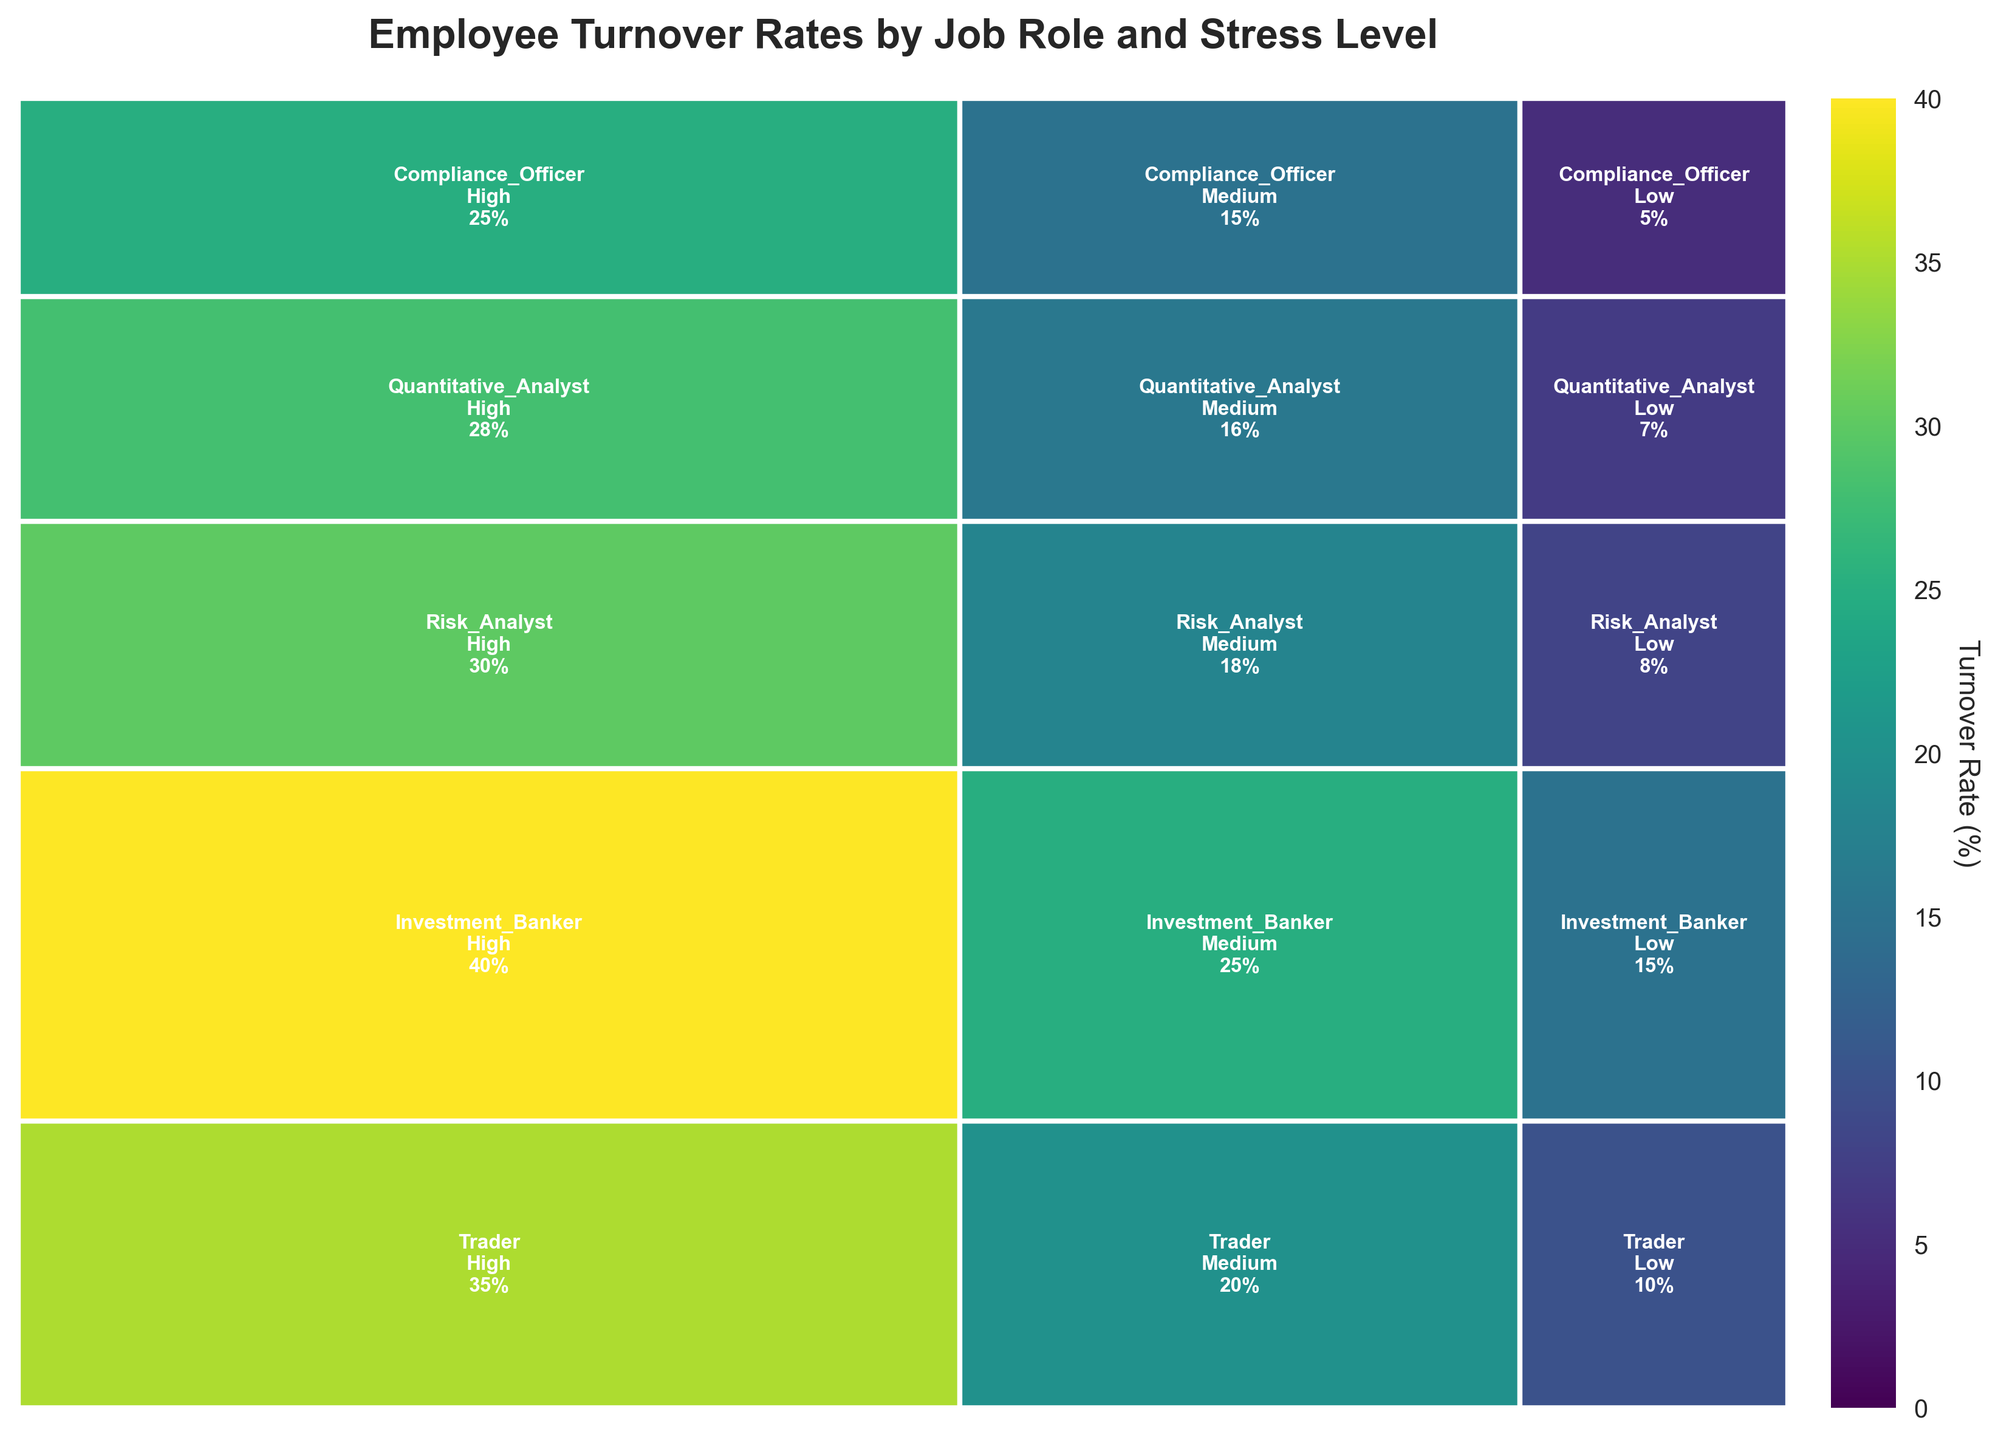How many job roles are displayed in the plot? The plot shows one tile for each job role, with multiple subdivisions per stress level. Counting the distinct job roles, we have Trader, Investment Banker, Risk Analyst, Quantitative Analyst, and Compliance Officer.
Answer: 5 Which stress level leads to the highest turnover rate for Investment Bankers? Each stress level (High, Medium, Low) is indicated within the Investment Banker tile. By analyzing the values within this tile, the highest turnover rate is observed under the High stress level which is 40%.
Answer: High Which job role has the lowest turnover rate under high stress? Each job role within the high stress level (the leftmost side of the plot) has its corresponding turnover rate. Comparing these, Compliance Officer has the lowest turnover rate at 25%.
Answer: Compliance Officer What is the total turnover rate for Risk Analysts across all stress levels? Sum up the turnover rates for Risk Analysts: 30% (High) + 18% (Medium) + 8% (Low) = 56%.
Answer: 56% Compare the turnover rates of Traders and Compliance Officers under medium stress. By looking at the values within the medium stress level subdivisions for each job role, Traders have a turnover rate of 20%, while Compliance Officers have a turnover rate of 15%. Traders have a higher turnover rate.
Answer: Traders Which stress level shows the lowest turnover rate overall? Summing the turnovers by each stress level across all job roles: High = 35%+40%+30%+28%+25% = 158%, Medium = 20%+25%+18%+16%+15% = 94%, Low = 10%+15%+8%+7%+5% = 45%. The Low stress level has the lowest total turnover rate.
Answer: Low What portion of the total turnover rate does the Quantitative Analyst's turnover under high stress constitute? First, compute the total turnover rate for all roles and stress levels, which is 35+20+10+40+25+15+30+18+8+28+16+7+25+15+5 = 297%. The Quantitative Analyst's turnover under high stress is 28%, which makes (28 / 297) * 100 ≈ 9.43%.
Answer: 9.43% How does the turnover rate for Traders under low stress compare to that of Quantitative Analysts under medium stress? Within their respective subdivisions, Traders under low stress have a turnover rate of 10%, and Quantitative Analysts under medium stress have a turnover rate of 16%. Quantitative Analysts under medium stress have a higher turnover rate.
Answer: Quantitative Analysts under medium stress What is the median turnover rate for the Compliance Officer role across all stress levels? For Compliance Officers in High (25%), Medium (15%), and Low (5%), the rates are in ascending order: 5%, 15%, 25%. The median is 15%.
Answer: 15% What is the trend in turnover rates across stress levels for each job role? Analyzing each job role:
- Traders: High (35%), Medium (20%), Low (10%) - Decreasing
- Investment Bankers: High (40%), Medium (25%), Low (15%) - Decreasing
- Risk Analysts: High (30%), Medium (18%), Low (8%) - Decreasing
- Quantitative Analysts: High (28%), Medium (16%), Low (7%) - Decreasing
- Compliance Officers: High (25%), Medium (15%), Low (5%) - Decreasing
All roles show decreasing turnover rates as stress levels decrease.
Answer: Decreasing 